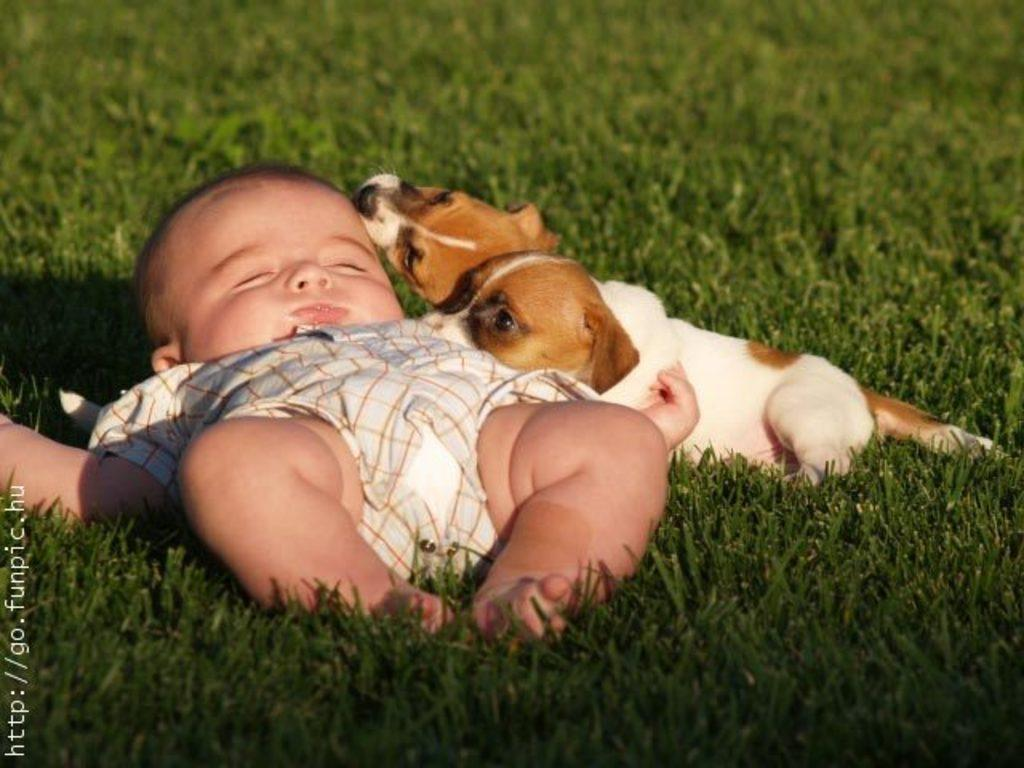What is the main subject of the image? There is a baby laying on the floor in the image. Are there any animals present in the image? Yes, there are two dogs in the image. What are the dogs doing in the image? The dogs are looking at the baby in the image. Can you describe any other objects in the image? There is a green color glass in the image. Can you tell me how many snails are crawling on the baby in the image? There are no snails present in the image; it only features a baby, two dogs, and a green color glass. What type of cherry is the baby holding in the image? There is no cherry present in the image; the baby is laying on the floor without any objects in their hands. 